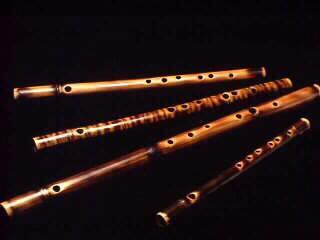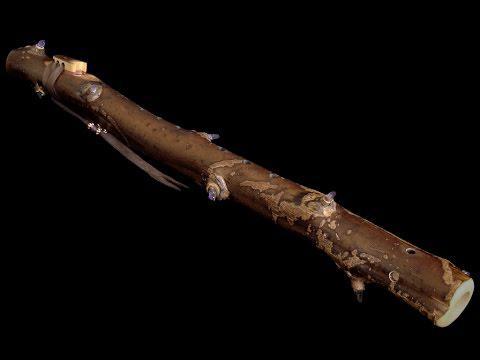The first image is the image on the left, the second image is the image on the right. Given the left and right images, does the statement "There is exactly one flute in the right image." hold true? Answer yes or no. Yes. The first image is the image on the left, the second image is the image on the right. Evaluate the accuracy of this statement regarding the images: "The combined images contain exactly five flute-related objects.". Is it true? Answer yes or no. Yes. 